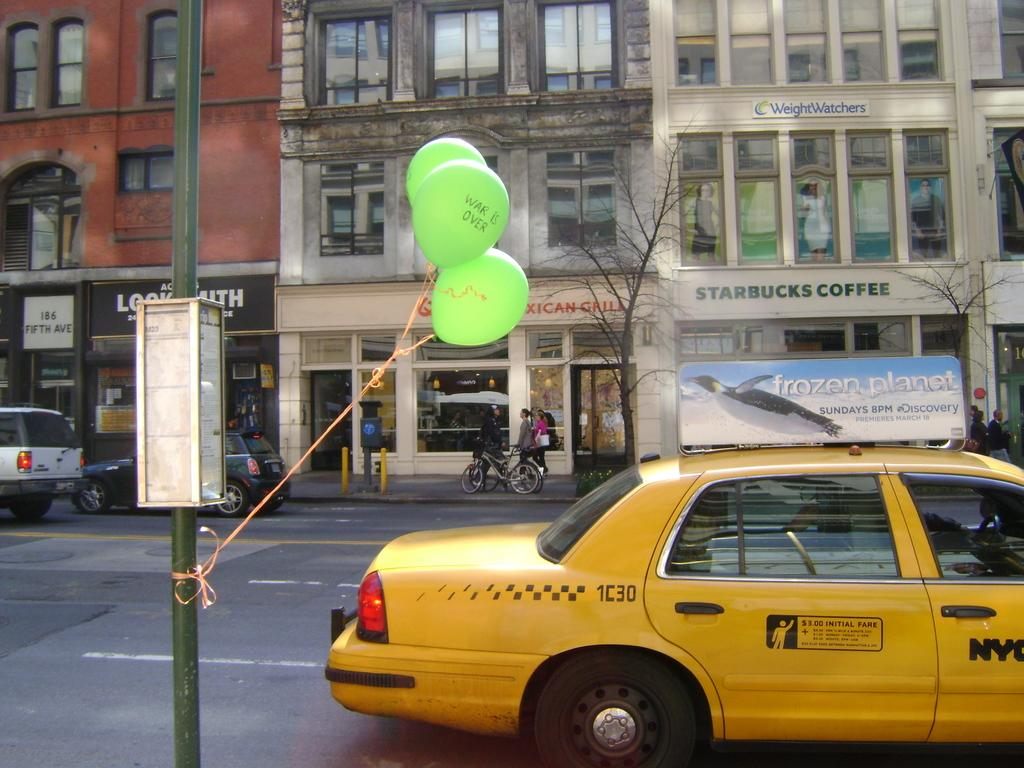<image>
Present a compact description of the photo's key features. A city scene with a taxi in front with a topper advertising a show called Frozen Planet. 